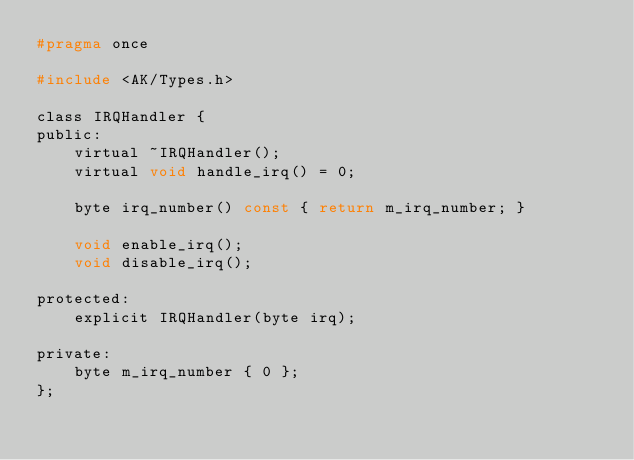Convert code to text. <code><loc_0><loc_0><loc_500><loc_500><_C_>#pragma once

#include <AK/Types.h>

class IRQHandler {
public:
    virtual ~IRQHandler();
    virtual void handle_irq() = 0;

    byte irq_number() const { return m_irq_number; }

    void enable_irq();
    void disable_irq();

protected:
    explicit IRQHandler(byte irq);

private:
    byte m_irq_number { 0 };
};

</code> 